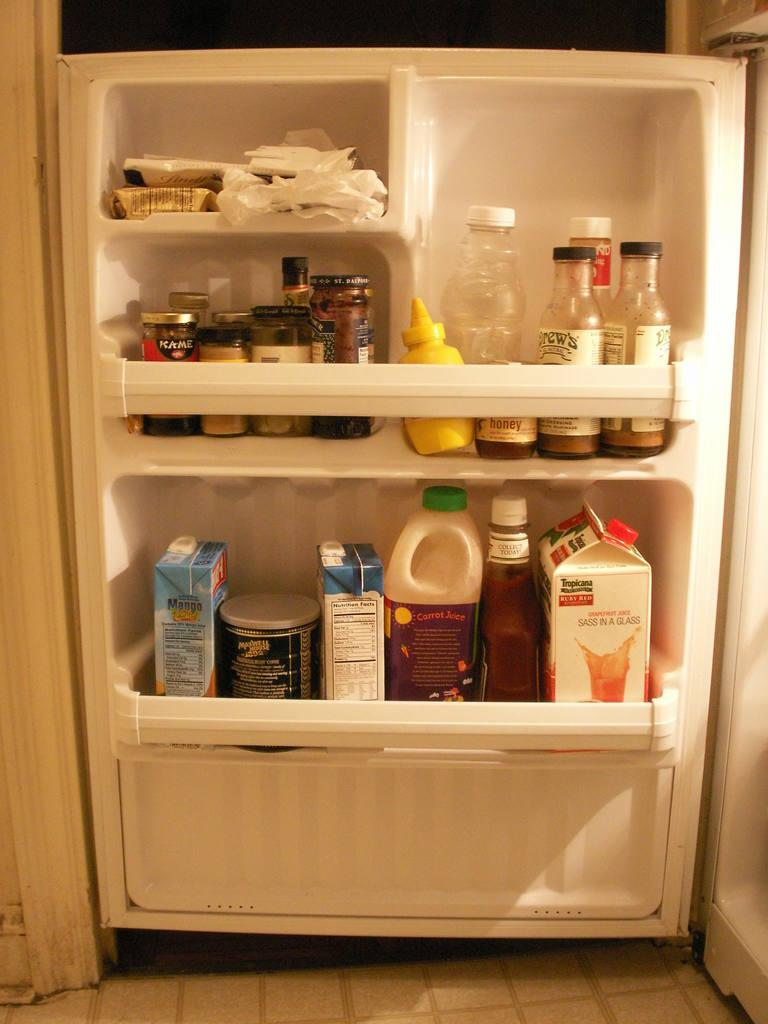<image>
Relay a brief, clear account of the picture shown. A refrigerator door contains many different products, including Tropicana Orange Juice and Maxwell House Coffee. 